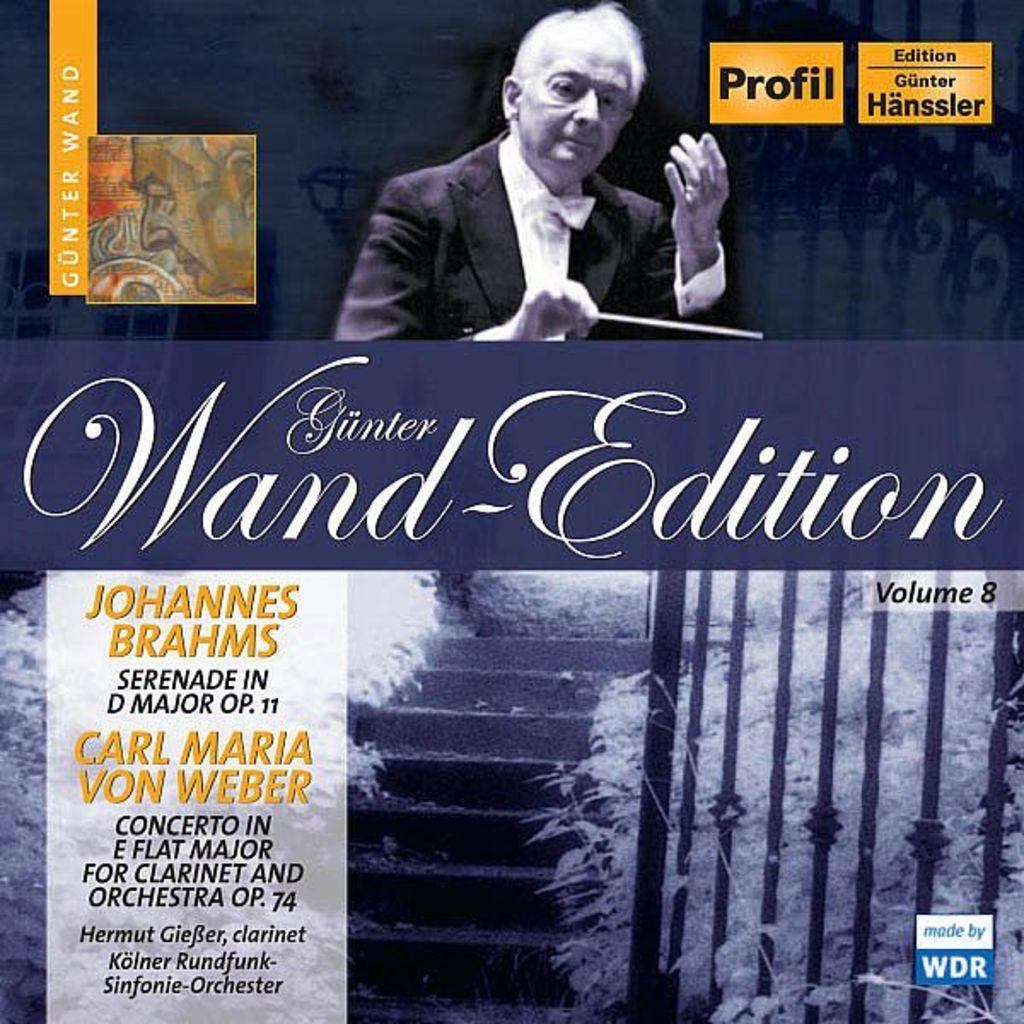<image>
Share a concise interpretation of the image provided. A book titled Gunter Wand-Edition with a male music conductor on the cover. 